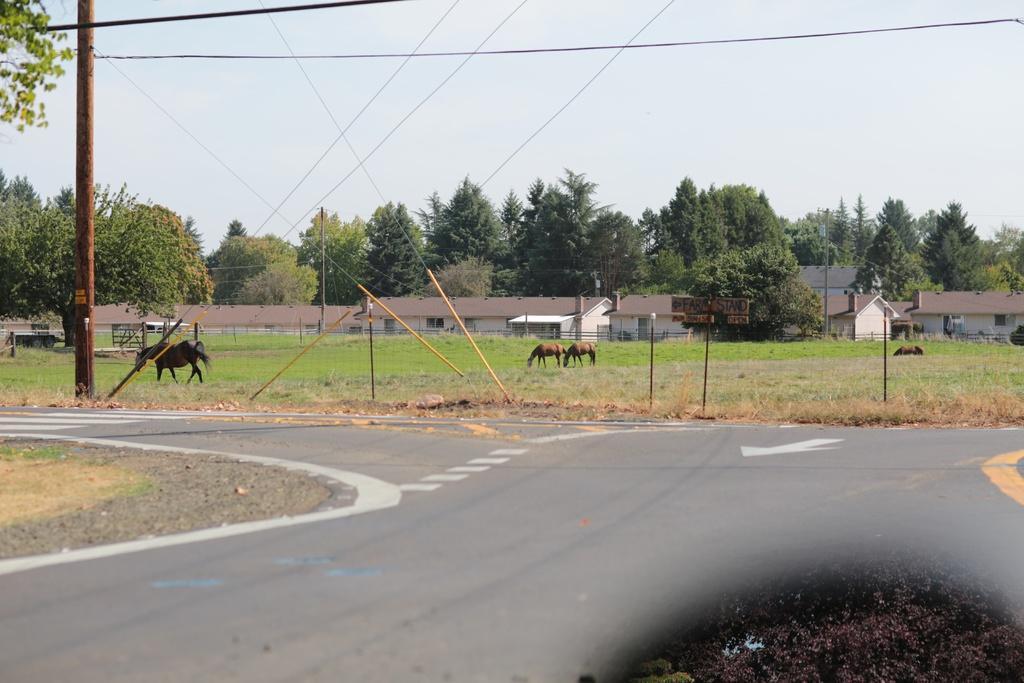Could you give a brief overview of what you see in this image? In this image we can see horses gazing, road, stones, buildings, electric poles, electric cables, trees and sky. 